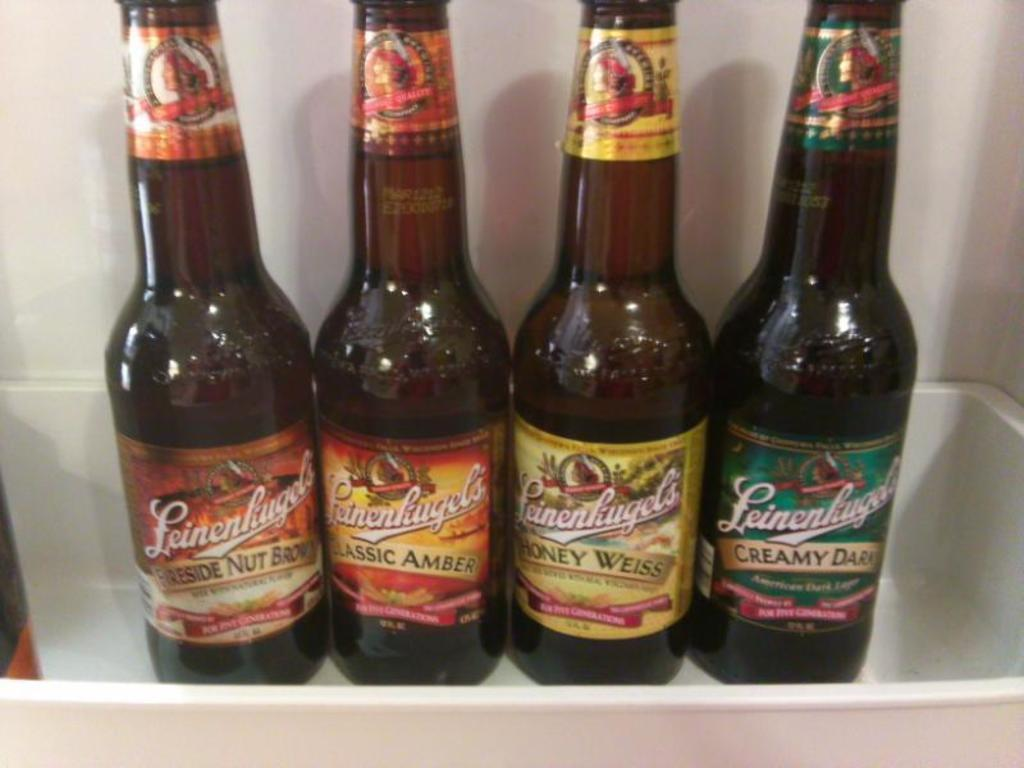<image>
Describe the image concisely. the word creamy is on the bottle of liquid 